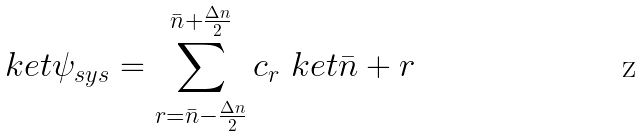Convert formula to latex. <formula><loc_0><loc_0><loc_500><loc_500>\ k e t { \psi _ { s y s } } = \sum _ { r = \bar { n } - \frac { \Delta n } { 2 } } ^ { \bar { n } + \frac { \Delta n } { 2 } } c _ { r } \ k e t { \bar { n } + r }</formula> 